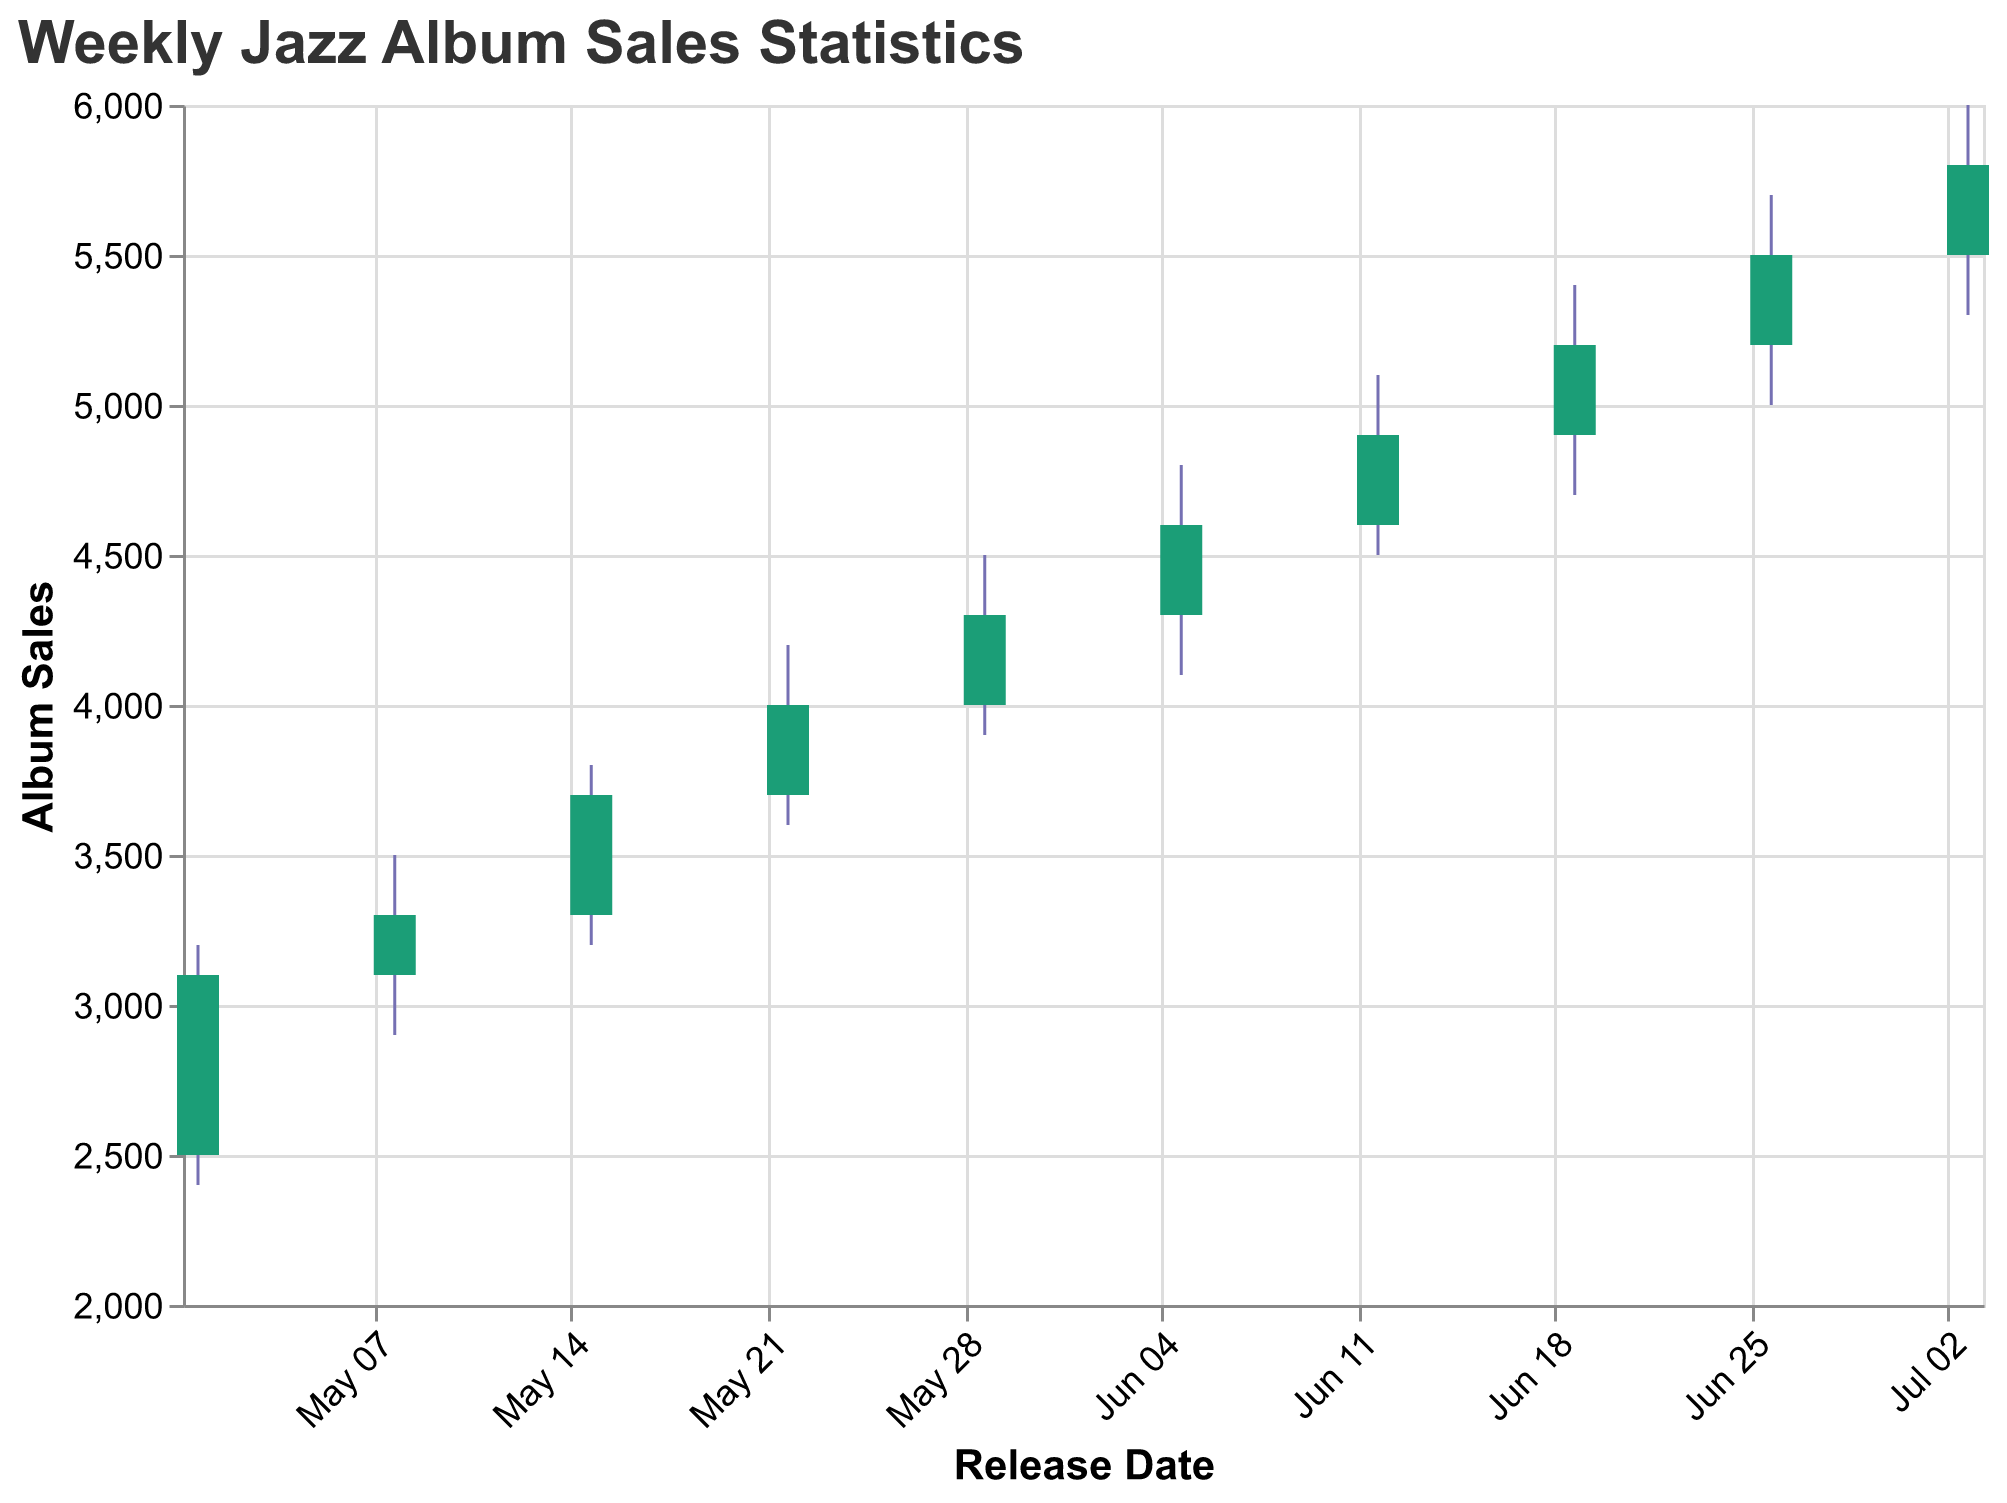How many weeks of album sales data are presented in the chart? Count the number of data points on the x-axis, each representing a week of album sales.
Answer: 10 Which album had the highest sales close value, and what was that value? Find the album with the highest value at the top of the final vertical bar representing the close value.
Answer: Latin Jazz Fiesta, 5800 Which album sales showed the largest range (difference between high and low values) in a week? Calculate the difference between high and low values for each album and identify the one with the largest difference. The range is High - Low.
Answer: Latin Jazz Fiesta, 700 What was the average weekly sales opening value for the top jazz releases in May 2023? Add up the opening values for albums released in May, which are 2500, 3100, 3300, 3700, and 4000, and divide by the number of albums. (2500 + 3100 + 3300 + 3700 + 4000) / 5 = 3320
Answer: 3320 Which album had the largest increase in sales from its opening value to its closing value? Find the difference (Close - Open) for each album and identify the largest increase. Calculate for each week and compare.
Answer: Smooth Sax Nights, 600 Between "Jazz Fusion Explosion" and "Bebop Renaissance," which album had a higher closing value and by how much? Compare the close values of the two albums: Jazz Fusion Explosion (4000) and Bebop Renaissance (4300). Subtract the smaller value from the larger value to find the difference. 4300 - 4000 = 300
Answer: Bebop Renaissance, 300 What was the trend in the closing values of album sales from May to July 2023? Observe the trend in the closing values plotted from May 1 to July 3 to identify if there is an upward or downward trend or if it remains steady.
Answer: Upward trend Identify the week with the narrowest range of sales values (high-low). What was the specific week and album? Calculate the difference (High - Low) for each week and identify the smallest range. The week and the corresponding album: Smooth Sax Nights (3200 - 2400) = 800
Answer: May 1, Smooth Sax Nights Which album had the highest selling price at any given point, and what was that value? Look for the highest value on the chart which represents the peak of the highest point indicated on the High y-axis.
Answer: Latin Jazz Fiesta, 6000 